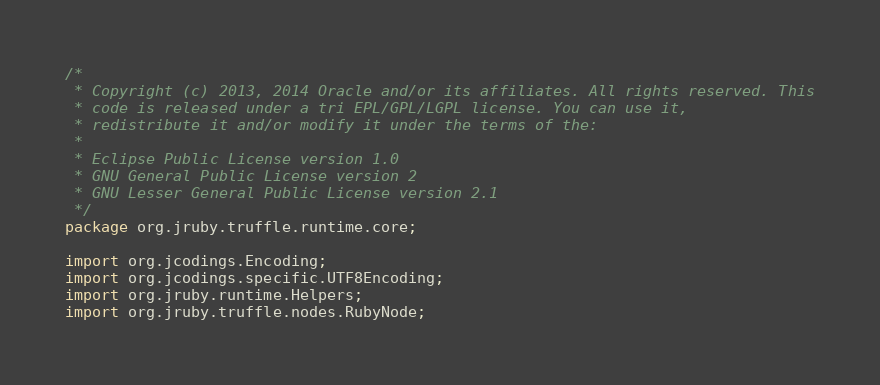Convert code to text. <code><loc_0><loc_0><loc_500><loc_500><_Java_>/*
 * Copyright (c) 2013, 2014 Oracle and/or its affiliates. All rights reserved. This
 * code is released under a tri EPL/GPL/LGPL license. You can use it,
 * redistribute it and/or modify it under the terms of the:
 *
 * Eclipse Public License version 1.0
 * GNU General Public License version 2
 * GNU Lesser General Public License version 2.1
 */
package org.jruby.truffle.runtime.core;

import org.jcodings.Encoding;
import org.jcodings.specific.UTF8Encoding;
import org.jruby.runtime.Helpers;
import org.jruby.truffle.nodes.RubyNode;</code> 